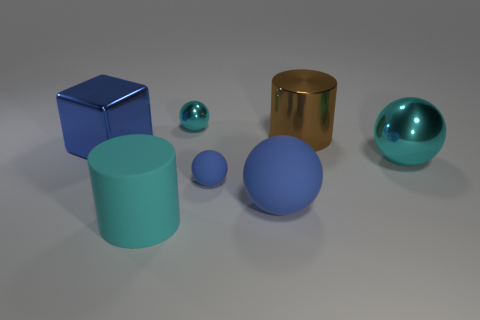Are the cylinder that is in front of the blue shiny thing and the small cyan thing made of the same material?
Offer a terse response. No. There is a cylinder in front of the cyan thing that is on the right side of the big sphere to the left of the large shiny ball; what is its material?
Keep it short and to the point. Rubber. What number of other objects are there of the same shape as the brown metal thing?
Provide a short and direct response. 1. There is a large cylinder that is to the right of the small cyan metallic thing; what is its color?
Your response must be concise. Brown. There is a big blue thing that is on the right side of the cylinder in front of the large brown metallic thing; what number of shiny blocks are behind it?
Your answer should be very brief. 1. How many big brown shiny objects are left of the big brown cylinder that is behind the big rubber sphere?
Make the answer very short. 0. There is a cyan matte thing; what number of metallic balls are behind it?
Give a very brief answer. 2. What number of other things are there of the same size as the cyan cylinder?
Your answer should be very brief. 4. The other object that is the same shape as the brown object is what size?
Your answer should be very brief. Large. The large shiny object that is on the right side of the large brown object has what shape?
Provide a short and direct response. Sphere. 